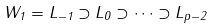Convert formula to latex. <formula><loc_0><loc_0><loc_500><loc_500>W _ { 1 } = L _ { - 1 } \supset L _ { 0 } \supset \dots \supset L _ { p - 2 }</formula> 